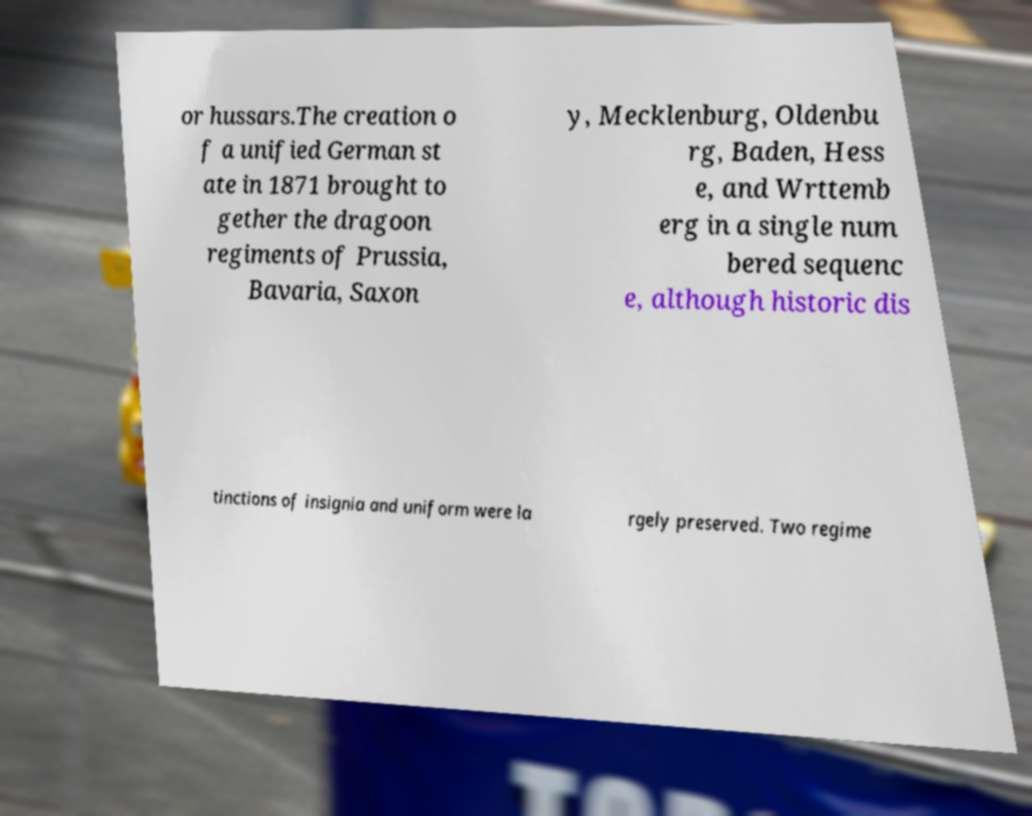What messages or text are displayed in this image? I need them in a readable, typed format. or hussars.The creation o f a unified German st ate in 1871 brought to gether the dragoon regiments of Prussia, Bavaria, Saxon y, Mecklenburg, Oldenbu rg, Baden, Hess e, and Wrttemb erg in a single num bered sequenc e, although historic dis tinctions of insignia and uniform were la rgely preserved. Two regime 